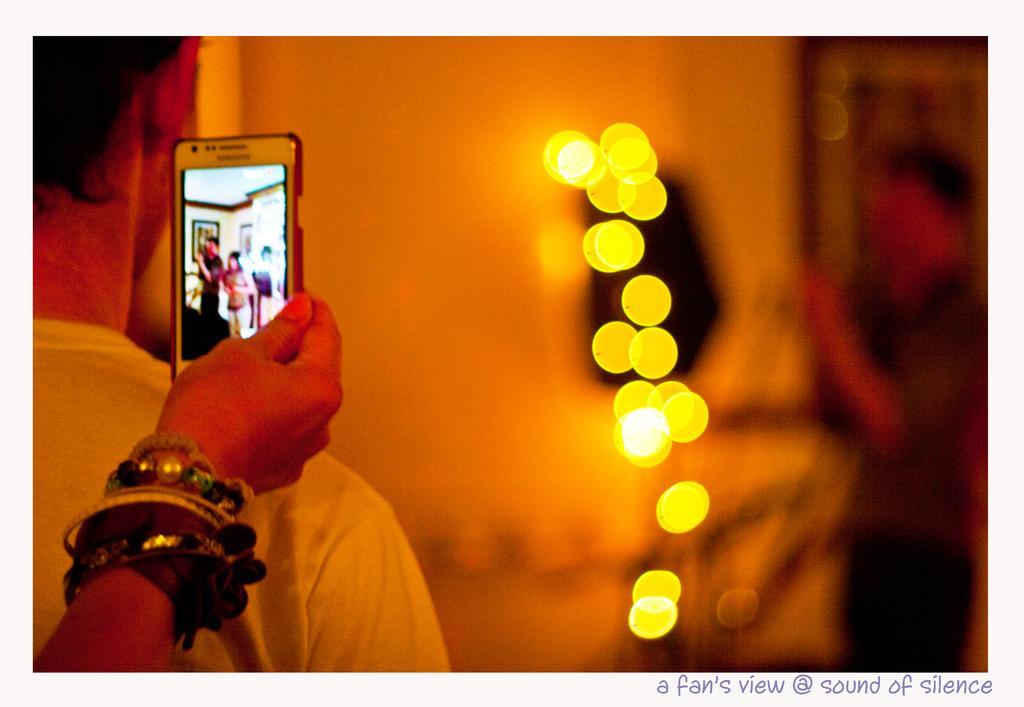Describe this image in one or two sentences. In this image there are two person's, a person holding a mobile, and there is blur background and a watermark on the image. 